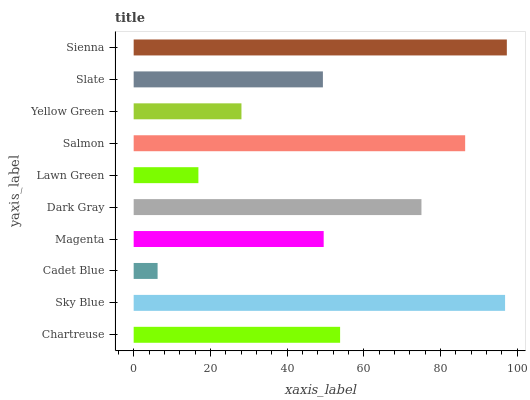Is Cadet Blue the minimum?
Answer yes or no. Yes. Is Sienna the maximum?
Answer yes or no. Yes. Is Sky Blue the minimum?
Answer yes or no. No. Is Sky Blue the maximum?
Answer yes or no. No. Is Sky Blue greater than Chartreuse?
Answer yes or no. Yes. Is Chartreuse less than Sky Blue?
Answer yes or no. Yes. Is Chartreuse greater than Sky Blue?
Answer yes or no. No. Is Sky Blue less than Chartreuse?
Answer yes or no. No. Is Chartreuse the high median?
Answer yes or no. Yes. Is Magenta the low median?
Answer yes or no. Yes. Is Sienna the high median?
Answer yes or no. No. Is Lawn Green the low median?
Answer yes or no. No. 